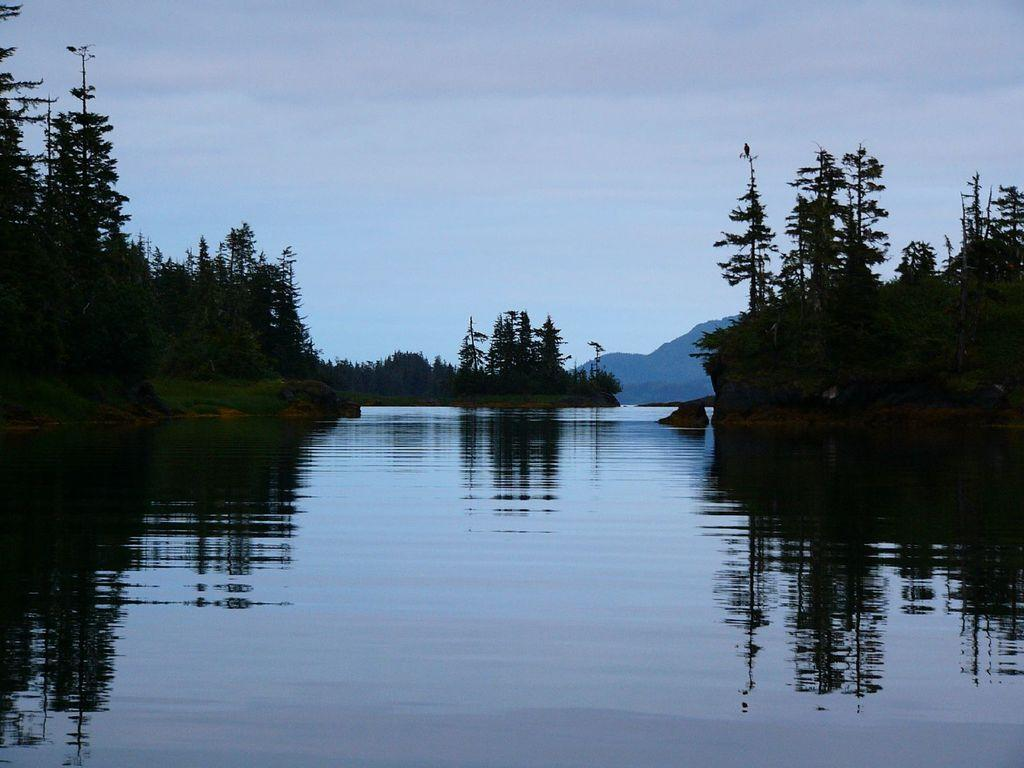What type of vegetation can be seen in the image? There are many trees in the image. What natural feature is visible in the image? There is a river visible in the image. What can be seen in the distance in the image? There is a mountain in the background of the image. What is visible at the top of the image? The sky is visible at the top of the image. What can be observed in the sky? Clouds are present in the sky. Can you tell me how many roses are growing near the river in the image? There are no roses visible in the image; it features trees, a river, a mountain, and clouds in the sky. Are there any boys playing near the mountain in the image? There are no boys present in the image; it only shows trees, a river, a mountain, and clouds in the sky. 